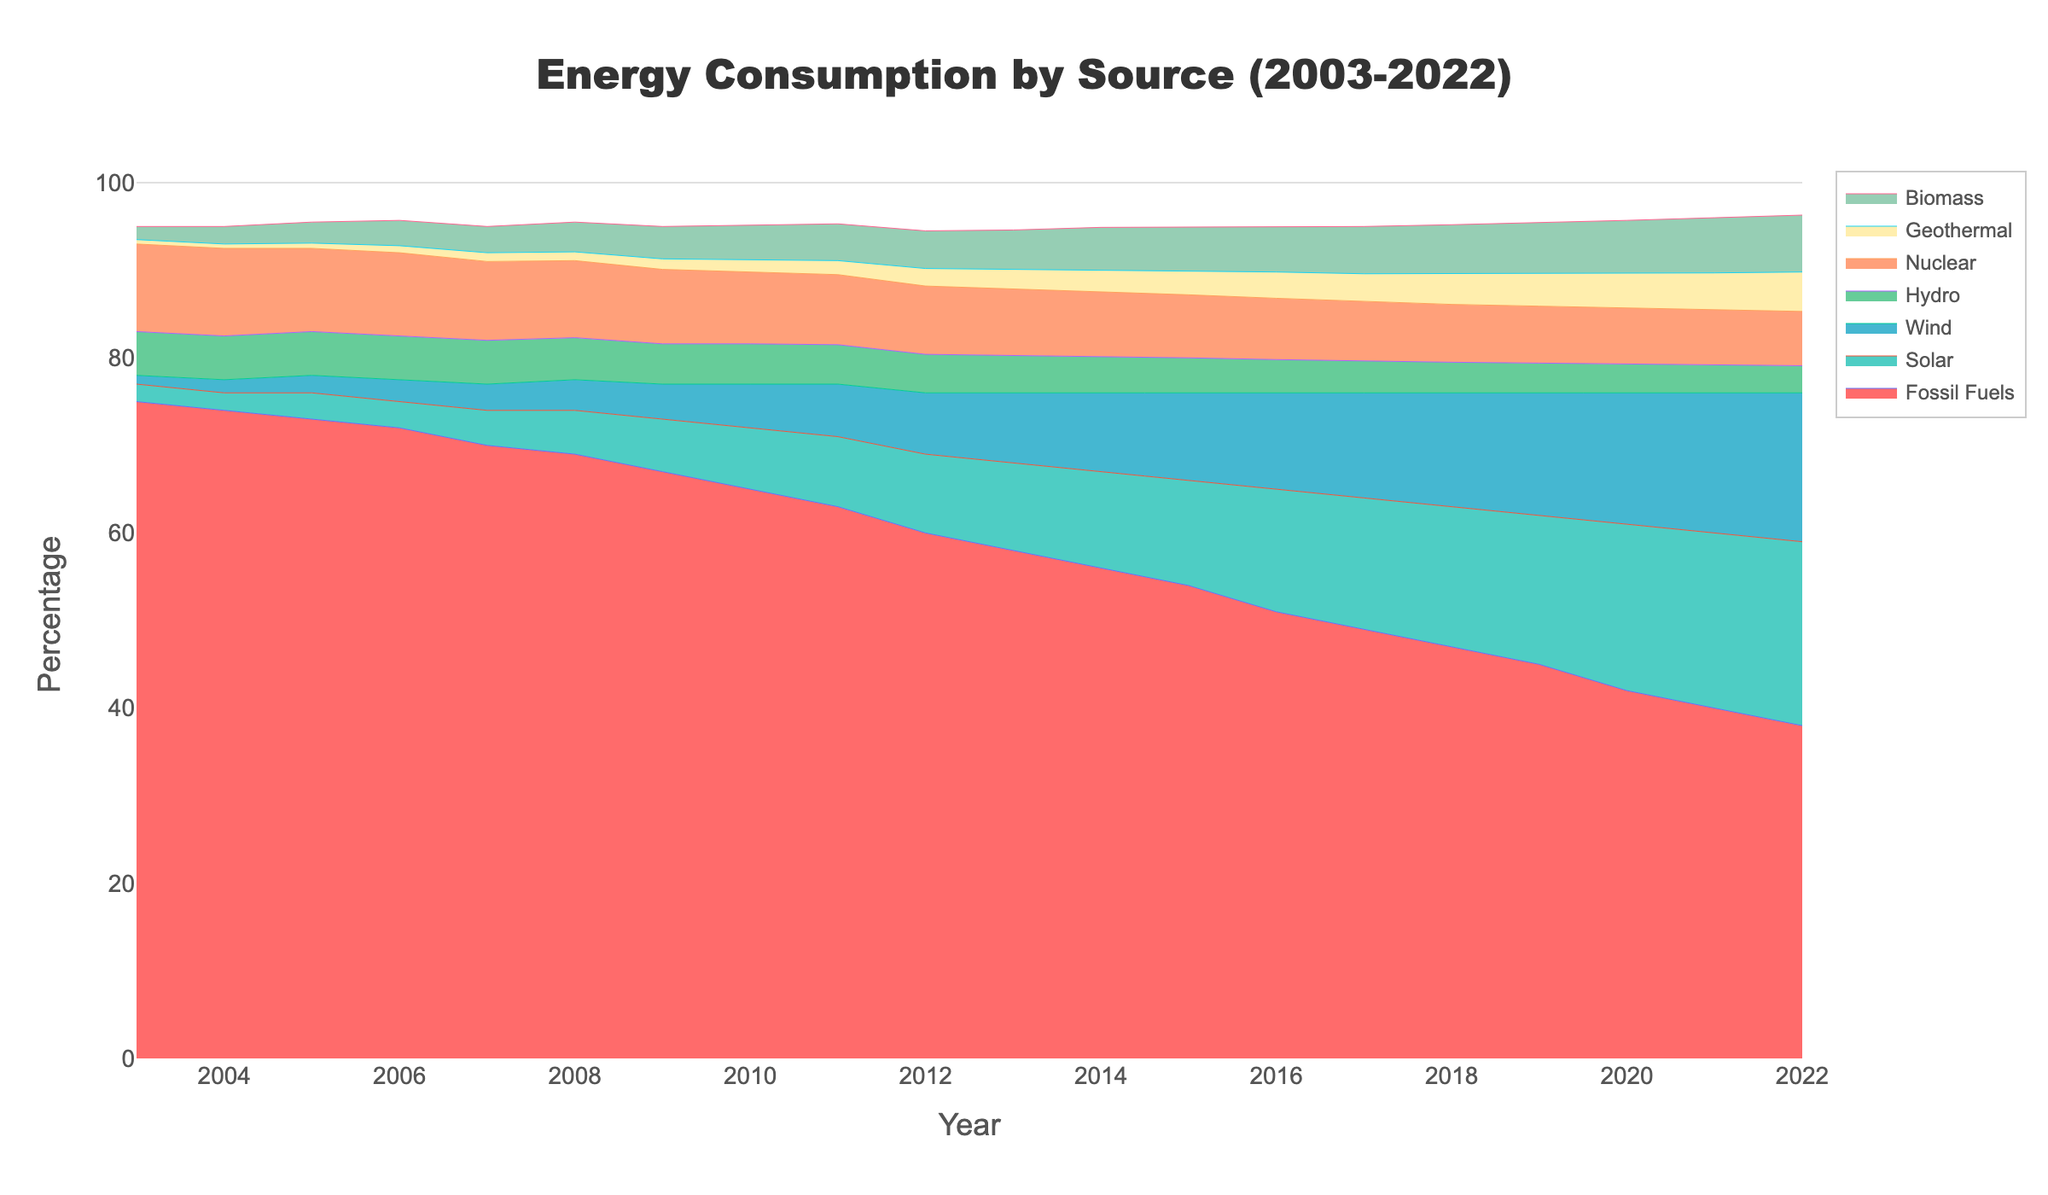How has the percentage of consumption from fossil fuels changed from 2003 to 2022? To determine the change in fossil fuel consumption, compare the percentage in 2003 (75%) to the percentage in 2022 (38%).
Answer: It has decreased by 37% Which renewable energy source saw the highest increase in percentage consumption from 2003 to 2022? Identify the renewable energy source with the highest increase by comparing their percentages in 2003 and 2022. Solar increased from 2% to 21%, a 19% increase. Wind increased from 1% to 17%, a 16% increase. Biomass increased from 1.5% to 6.5%, a 5% increase. This shows solar had the highest increase.
Answer: Solar energy What was the combined percentage of geothermal and biomass energy consumption in 2015? Add the percentages of geothermal and biomass in 2015 (2.7% for geothermal and 5% for biomass).
Answer: 7.7% Which year saw the steepest decline in fossil fuel consumption? Observe the trend in the fossil fuel consumption line and identify where the steepest decline happens. Between 2019 (45%) and 2020 (42%), there's a 3% drop. This is the steepest single-year decline.
Answer: 2019 to 2020 In which year did wind energy consumption first exceed hydro energy consumption? Compare the percentages of wind and hydro energy year by year. It first happened in 2016 when wind was at 11% and hydro at 3.8%.
Answer: 2016 How did nuclear energy consumption change from 2003 to 2022? Compare the nuclear energy consumption from 2003 (10%) to 2022 (6.2%).
Answer: It decreased by 3.8% Which energy source had the smallest change in percentage consumption from 2003 to 2022? Determine the change in percentage for each energy source from 2003 to 2022 and identify the smallest change. Hydro went from 5% to 3.1%, a change of -1.9%.
Answer: Hydro energy What is the average percentage of solar energy consumption from 2018 to 2022? Calculate the average by adding the solar percentages from 2018 (16%), 2019 (17%), 2020 (19%), 2021 (20%), and 2022 (21%) then divide by 5. (16 + 17 + 19 + 20 + 21) / 5 = 18.6%.
Answer: 18.6% Compare the percentage of fossil fuels consumption in 2010 to wind energy consumption in 2022. Compare 65% (fossil fuels in 2010) with 17% (wind in 2022). Fossil fuels in 2010 are much higher.
Answer: Fossil fuels were higher in 2010 Which year saw the highest consumption of geothermal energy? Look for the highest percentage value in the geothermal energy line. It reaches its highest at 4.5% in 2022.
Answer: 2022 